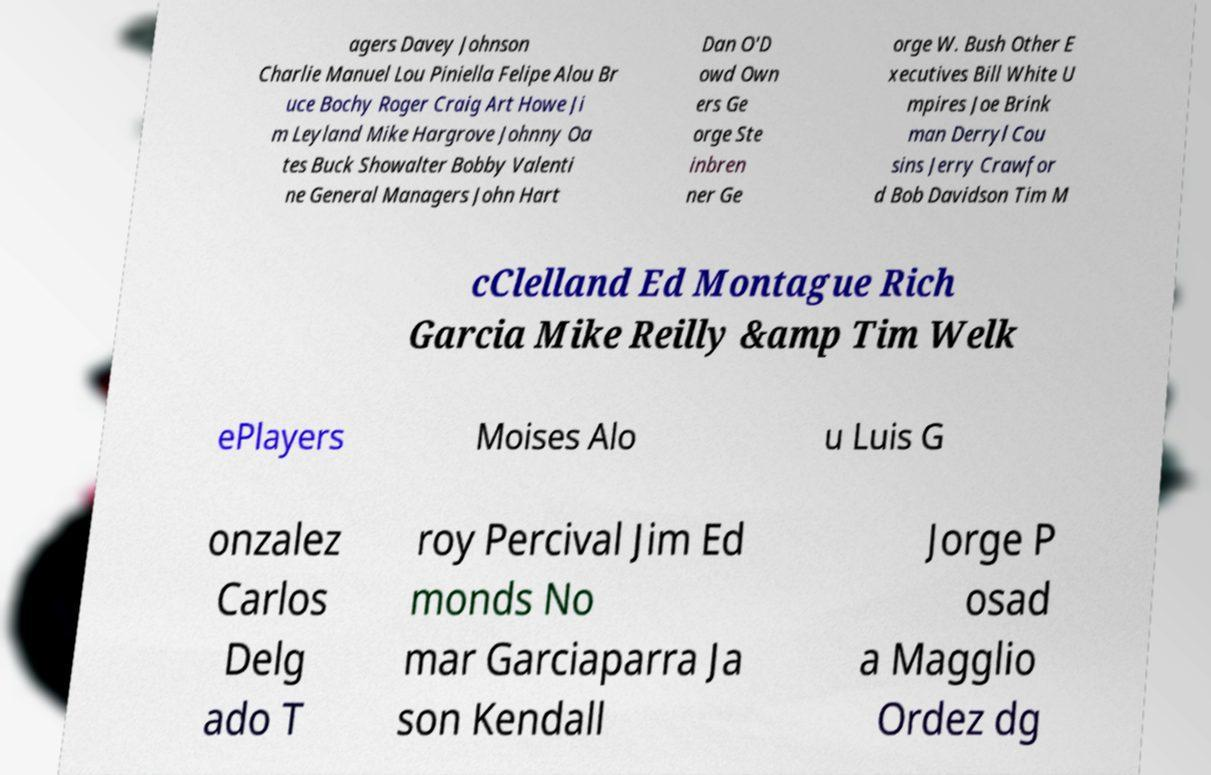What messages or text are displayed in this image? I need them in a readable, typed format. agers Davey Johnson Charlie Manuel Lou Piniella Felipe Alou Br uce Bochy Roger Craig Art Howe Ji m Leyland Mike Hargrove Johnny Oa tes Buck Showalter Bobby Valenti ne General Managers John Hart Dan O'D owd Own ers Ge orge Ste inbren ner Ge orge W. Bush Other E xecutives Bill White U mpires Joe Brink man Derryl Cou sins Jerry Crawfor d Bob Davidson Tim M cClelland Ed Montague Rich Garcia Mike Reilly &amp Tim Welk ePlayers Moises Alo u Luis G onzalez Carlos Delg ado T roy Percival Jim Ed monds No mar Garciaparra Ja son Kendall Jorge P osad a Magglio Ordez dg 